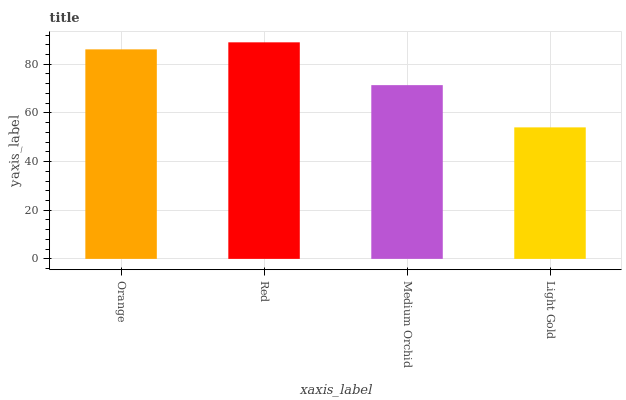Is Light Gold the minimum?
Answer yes or no. Yes. Is Red the maximum?
Answer yes or no. Yes. Is Medium Orchid the minimum?
Answer yes or no. No. Is Medium Orchid the maximum?
Answer yes or no. No. Is Red greater than Medium Orchid?
Answer yes or no. Yes. Is Medium Orchid less than Red?
Answer yes or no. Yes. Is Medium Orchid greater than Red?
Answer yes or no. No. Is Red less than Medium Orchid?
Answer yes or no. No. Is Orange the high median?
Answer yes or no. Yes. Is Medium Orchid the low median?
Answer yes or no. Yes. Is Light Gold the high median?
Answer yes or no. No. Is Orange the low median?
Answer yes or no. No. 